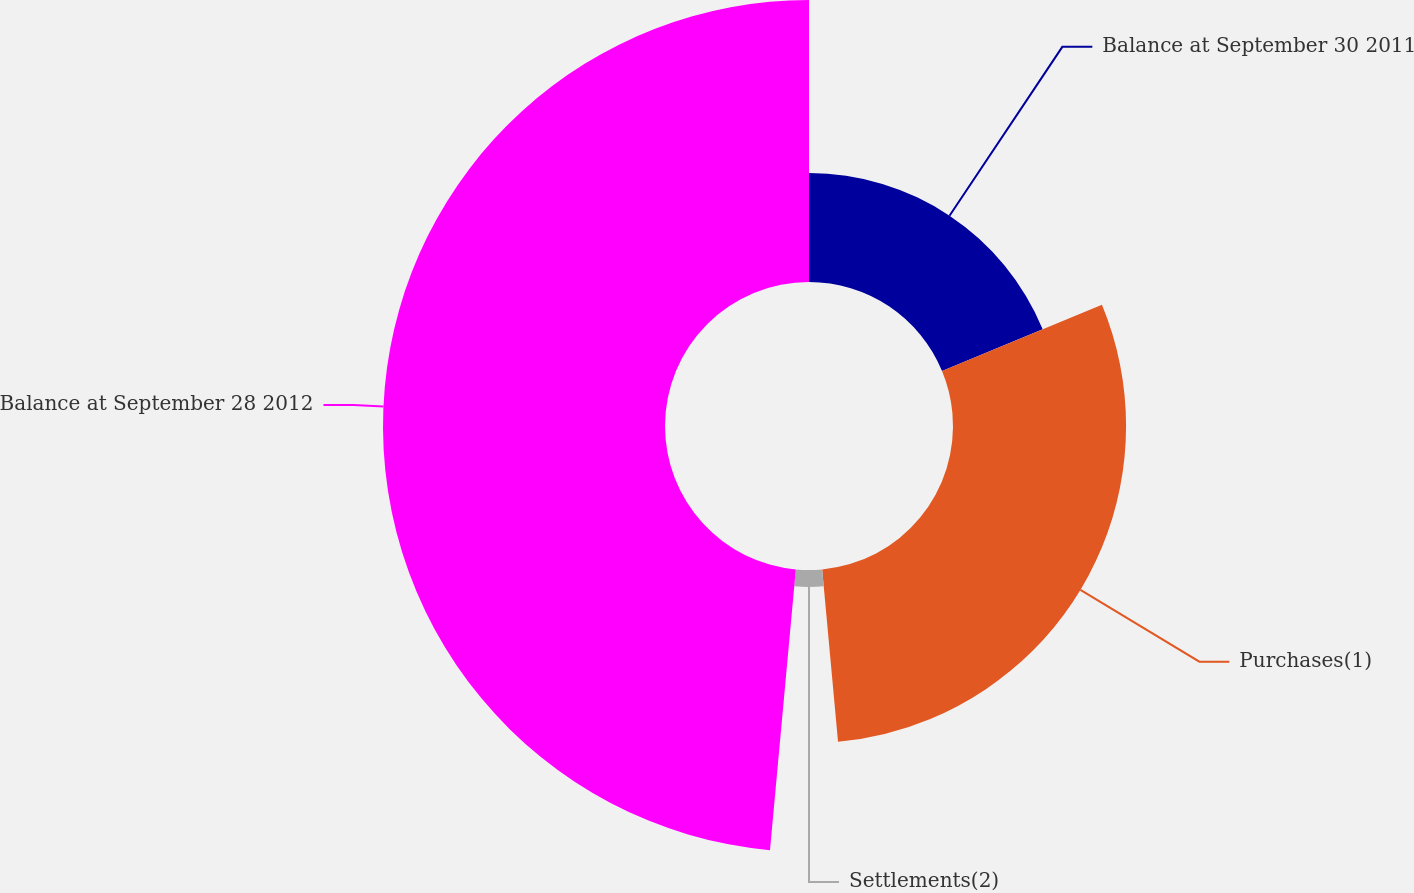Convert chart. <chart><loc_0><loc_0><loc_500><loc_500><pie_chart><fcel>Balance at September 30 2011<fcel>Purchases(1)<fcel>Settlements(2)<fcel>Balance at September 28 2012<nl><fcel>18.75%<fcel>29.79%<fcel>2.92%<fcel>48.54%<nl></chart> 